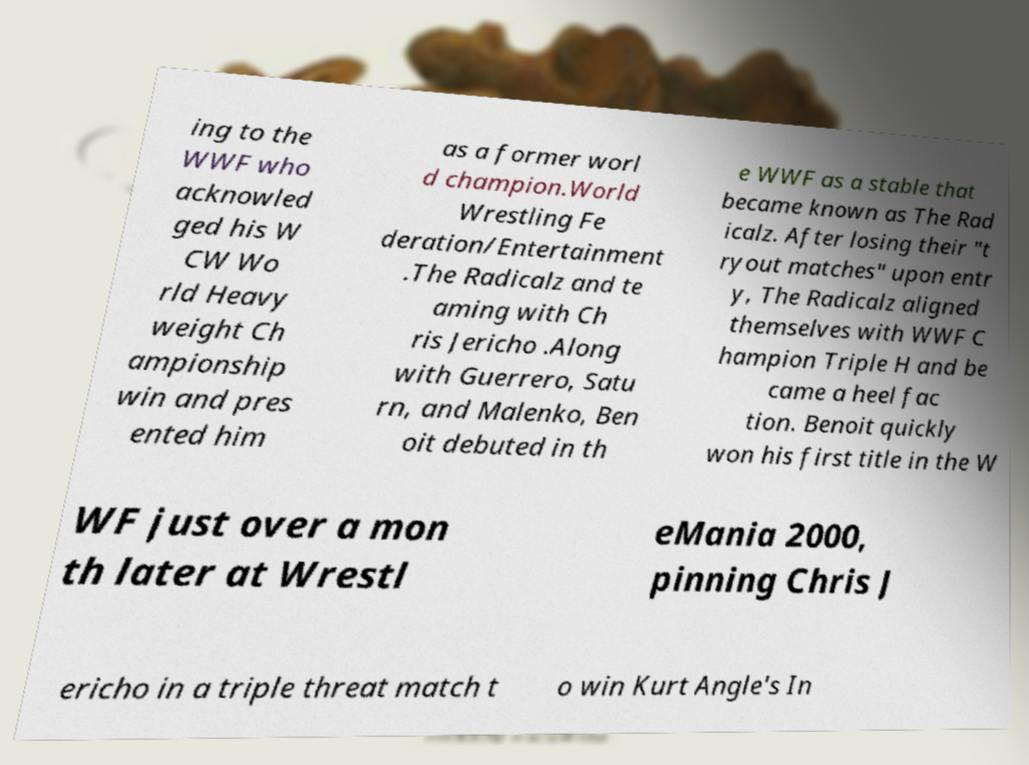Can you accurately transcribe the text from the provided image for me? ing to the WWF who acknowled ged his W CW Wo rld Heavy weight Ch ampionship win and pres ented him as a former worl d champion.World Wrestling Fe deration/Entertainment .The Radicalz and te aming with Ch ris Jericho .Along with Guerrero, Satu rn, and Malenko, Ben oit debuted in th e WWF as a stable that became known as The Rad icalz. After losing their "t ryout matches" upon entr y, The Radicalz aligned themselves with WWF C hampion Triple H and be came a heel fac tion. Benoit quickly won his first title in the W WF just over a mon th later at Wrestl eMania 2000, pinning Chris J ericho in a triple threat match t o win Kurt Angle's In 